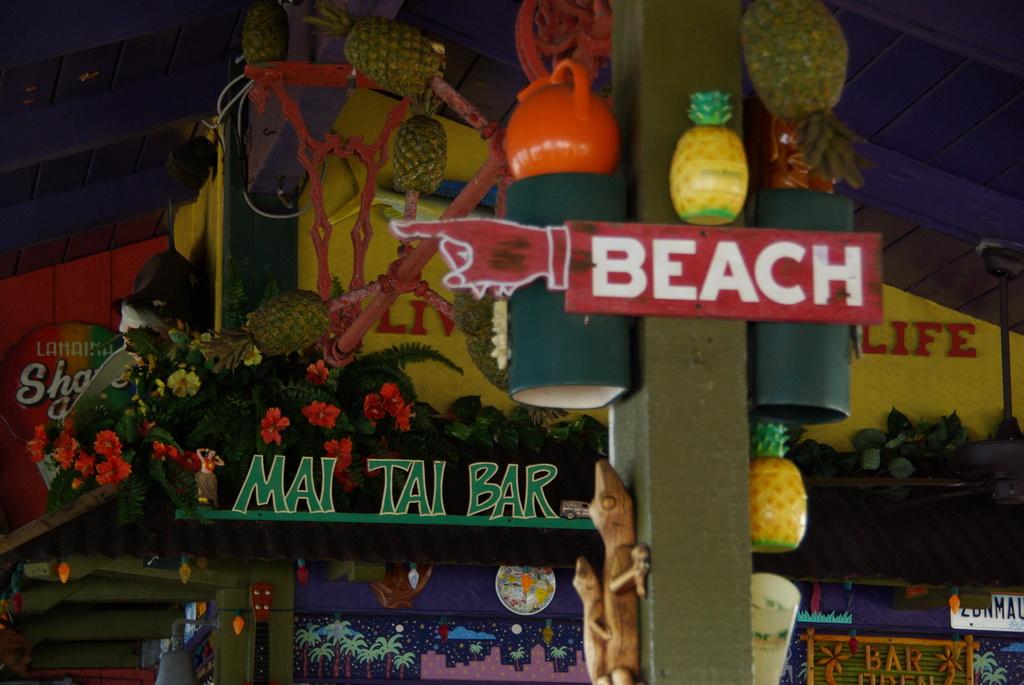What is the name of the bar?
Offer a terse response. Mai tai bar. Is there a beach?
Your answer should be compact. Yes. 